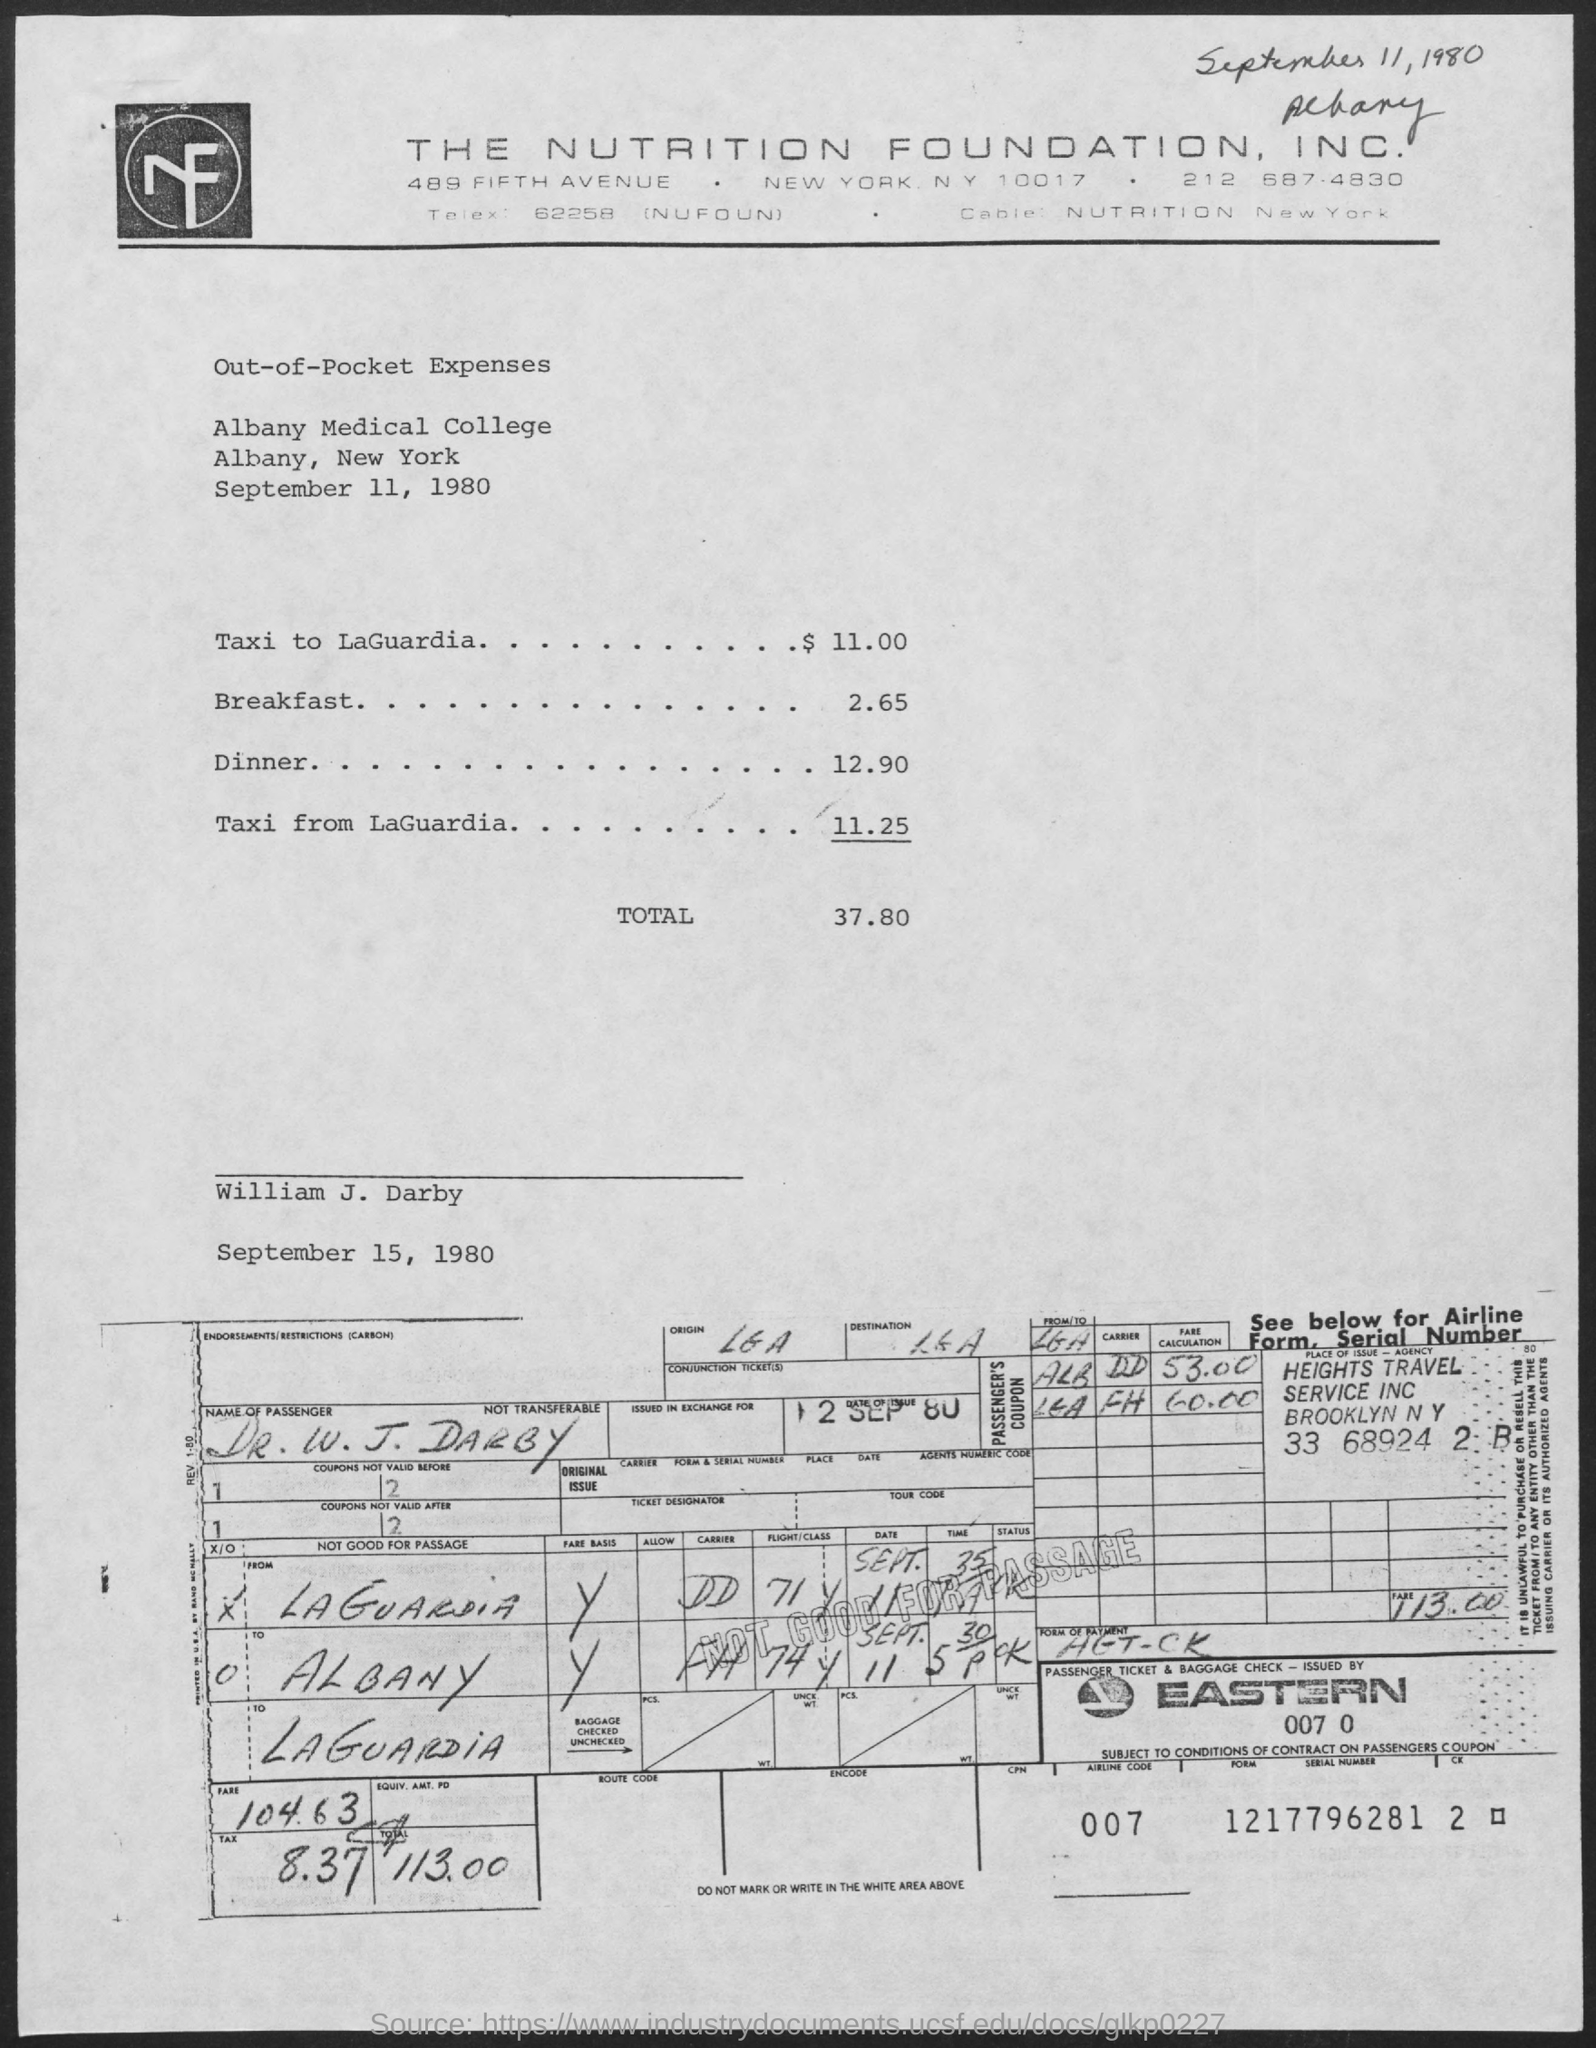What is the date mentioned on the top?
Keep it short and to the point. September 11, 1980. What is the total out-of-pocket expenses amount?
Ensure brevity in your answer.  37.80. What is the cost of dinner?
Your response must be concise. 12.90. What type of expenses are listed?
Your answer should be compact. Out-of-Pocket Expenses. What is the name of the passenger?
Ensure brevity in your answer.  Dr. W. J. Darby. 